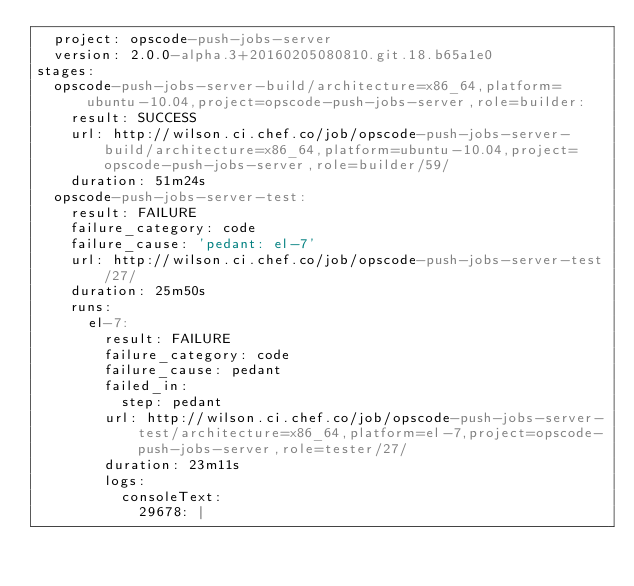Convert code to text. <code><loc_0><loc_0><loc_500><loc_500><_YAML_>  project: opscode-push-jobs-server
  version: 2.0.0-alpha.3+20160205080810.git.18.b65a1e0
stages:
  opscode-push-jobs-server-build/architecture=x86_64,platform=ubuntu-10.04,project=opscode-push-jobs-server,role=builder:
    result: SUCCESS
    url: http://wilson.ci.chef.co/job/opscode-push-jobs-server-build/architecture=x86_64,platform=ubuntu-10.04,project=opscode-push-jobs-server,role=builder/59/
    duration: 51m24s
  opscode-push-jobs-server-test:
    result: FAILURE
    failure_category: code
    failure_cause: 'pedant: el-7'
    url: http://wilson.ci.chef.co/job/opscode-push-jobs-server-test/27/
    duration: 25m50s
    runs:
      el-7:
        result: FAILURE
        failure_category: code
        failure_cause: pedant
        failed_in:
          step: pedant
        url: http://wilson.ci.chef.co/job/opscode-push-jobs-server-test/architecture=x86_64,platform=el-7,project=opscode-push-jobs-server,role=tester/27/
        duration: 23m11s
        logs:
          consoleText:
            29678: |</code> 